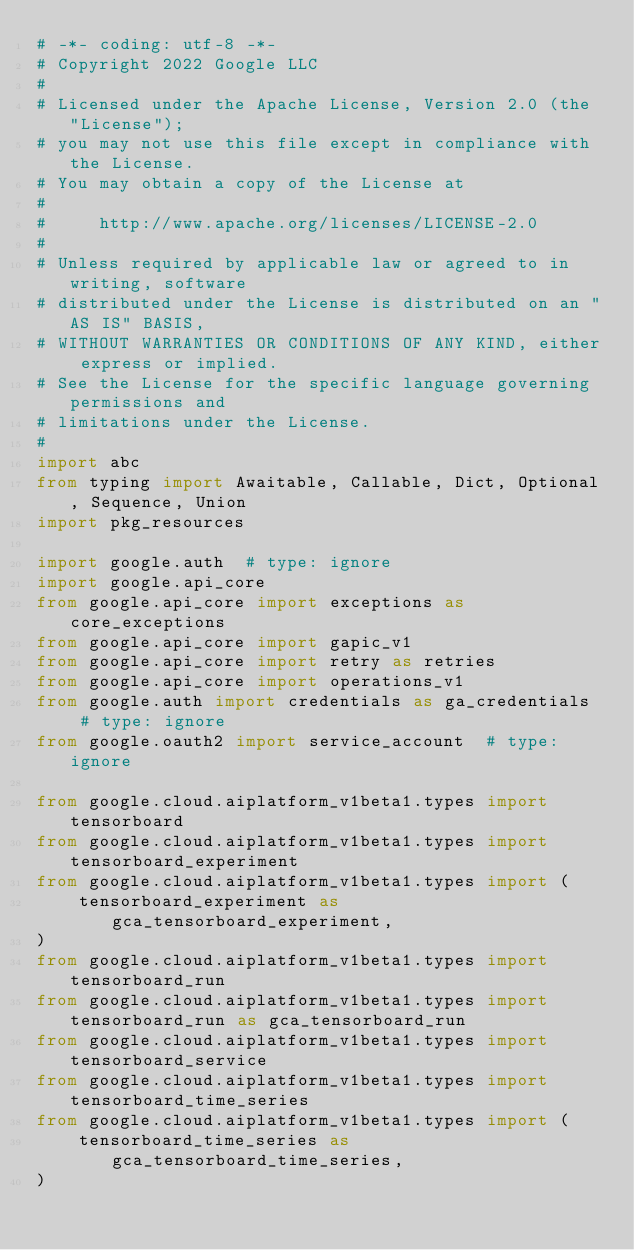Convert code to text. <code><loc_0><loc_0><loc_500><loc_500><_Python_># -*- coding: utf-8 -*-
# Copyright 2022 Google LLC
#
# Licensed under the Apache License, Version 2.0 (the "License");
# you may not use this file except in compliance with the License.
# You may obtain a copy of the License at
#
#     http://www.apache.org/licenses/LICENSE-2.0
#
# Unless required by applicable law or agreed to in writing, software
# distributed under the License is distributed on an "AS IS" BASIS,
# WITHOUT WARRANTIES OR CONDITIONS OF ANY KIND, either express or implied.
# See the License for the specific language governing permissions and
# limitations under the License.
#
import abc
from typing import Awaitable, Callable, Dict, Optional, Sequence, Union
import pkg_resources

import google.auth  # type: ignore
import google.api_core
from google.api_core import exceptions as core_exceptions
from google.api_core import gapic_v1
from google.api_core import retry as retries
from google.api_core import operations_v1
from google.auth import credentials as ga_credentials  # type: ignore
from google.oauth2 import service_account  # type: ignore

from google.cloud.aiplatform_v1beta1.types import tensorboard
from google.cloud.aiplatform_v1beta1.types import tensorboard_experiment
from google.cloud.aiplatform_v1beta1.types import (
    tensorboard_experiment as gca_tensorboard_experiment,
)
from google.cloud.aiplatform_v1beta1.types import tensorboard_run
from google.cloud.aiplatform_v1beta1.types import tensorboard_run as gca_tensorboard_run
from google.cloud.aiplatform_v1beta1.types import tensorboard_service
from google.cloud.aiplatform_v1beta1.types import tensorboard_time_series
from google.cloud.aiplatform_v1beta1.types import (
    tensorboard_time_series as gca_tensorboard_time_series,
)</code> 